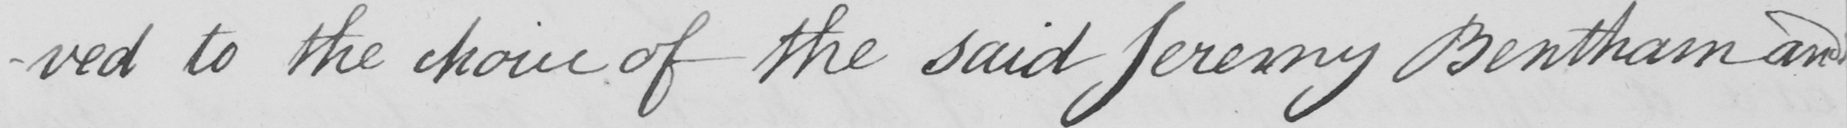What text is written in this handwritten line? -ved to the choice of the said Jeremy Bentham and 